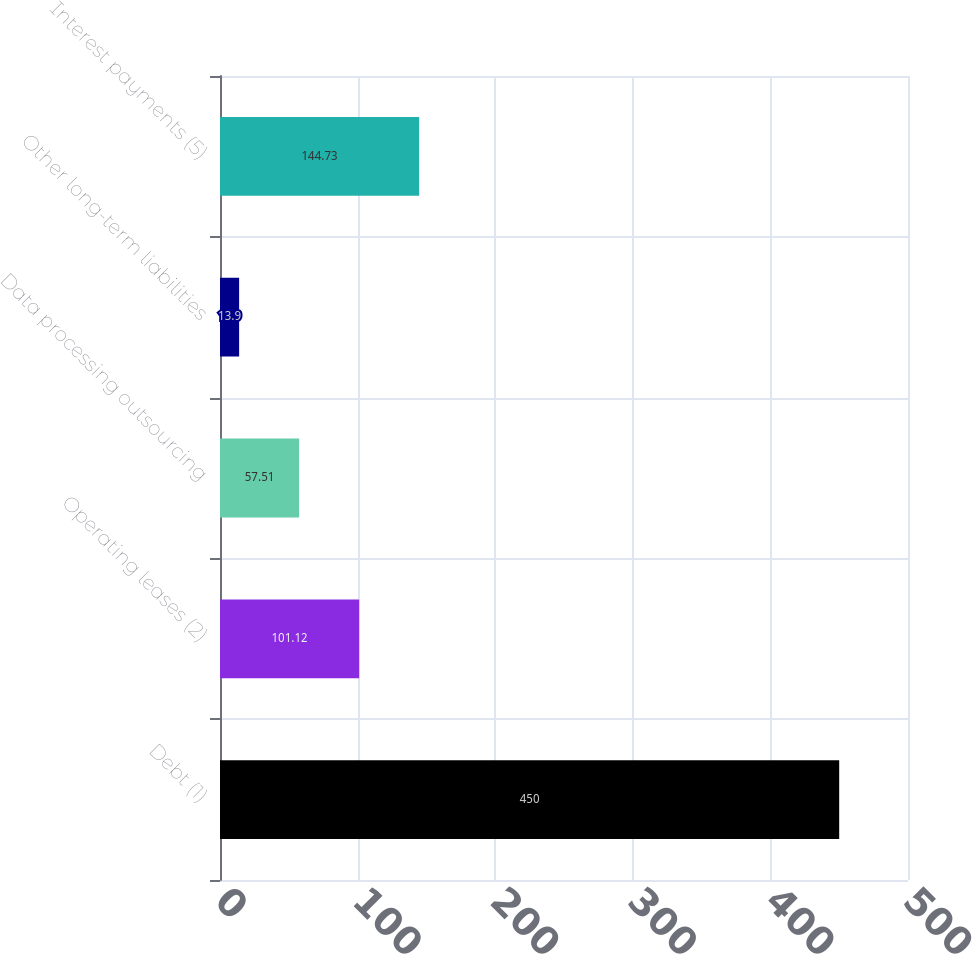<chart> <loc_0><loc_0><loc_500><loc_500><bar_chart><fcel>Debt (1)<fcel>Operating leases (2)<fcel>Data processing outsourcing<fcel>Other long-term liabilities<fcel>Interest payments (5)<nl><fcel>450<fcel>101.12<fcel>57.51<fcel>13.9<fcel>144.73<nl></chart> 